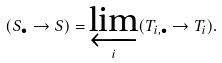Convert formula to latex. <formula><loc_0><loc_0><loc_500><loc_500>( S _ { \bullet } \to S ) = \varprojlim _ { i } ( T _ { i , \bullet } \to T _ { i } ) .</formula> 